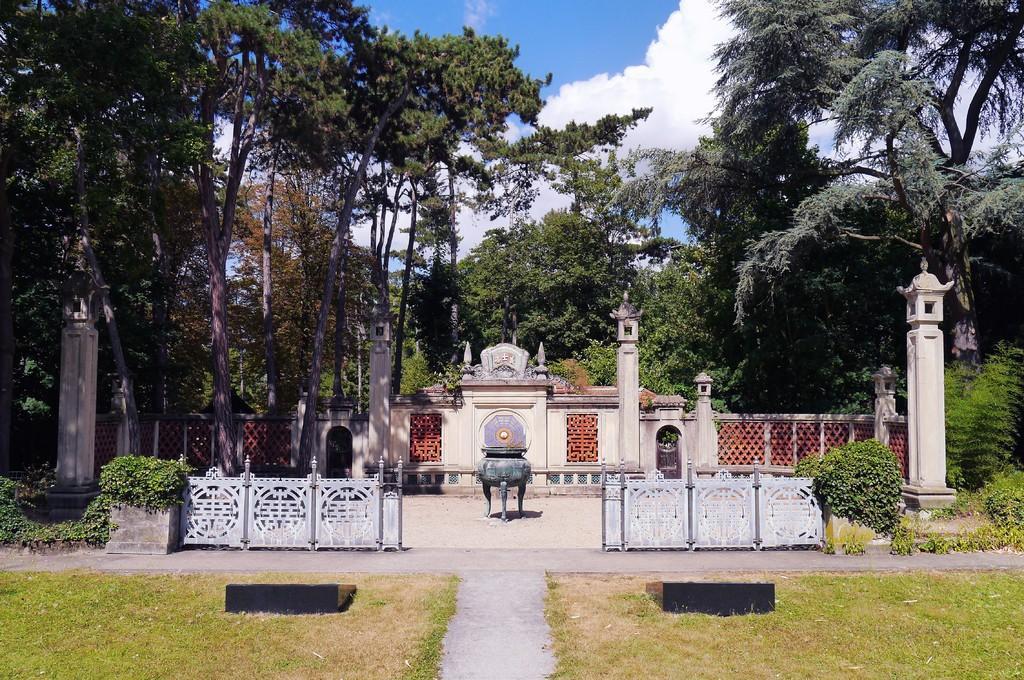Can you describe this image briefly? In foreground grass is there , a way between grass to walk. In the middle four pillars and a constructed designer wall. On the top we can see trees, sky and clouds. 